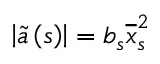Convert formula to latex. <formula><loc_0><loc_0><loc_500><loc_500>\left | \widetilde { a } \left ( s \right ) \right | = b _ { s } \overline { x } _ { s \, } ^ { 2 }</formula> 